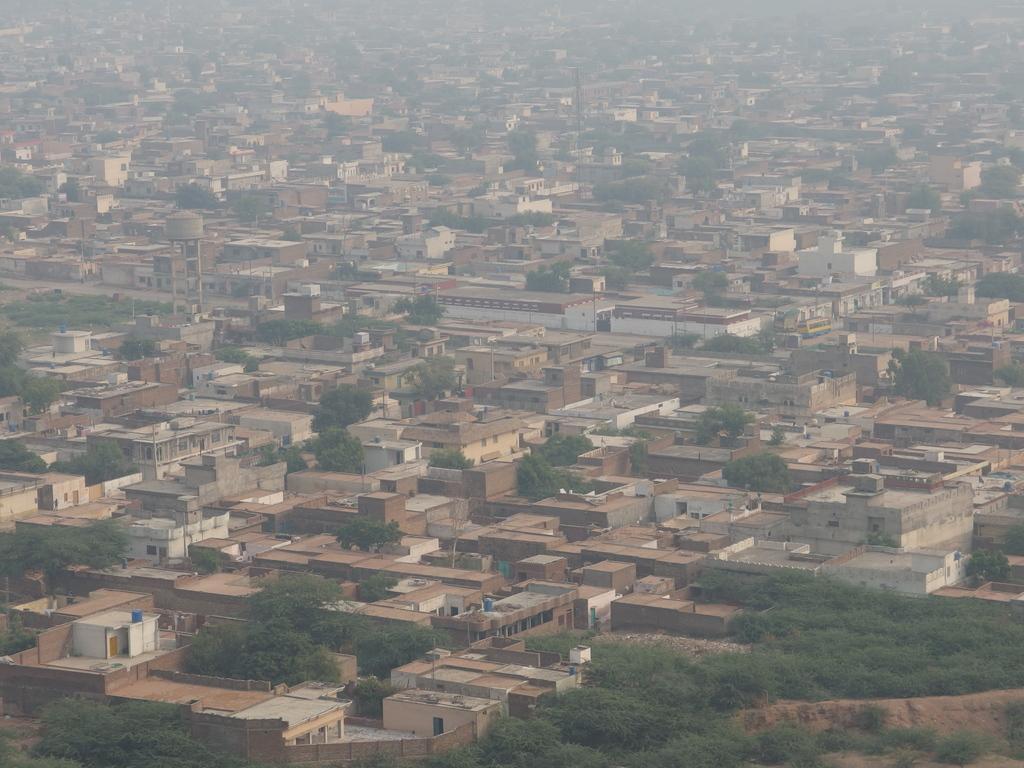Can you describe this image briefly? In the image we can see the houses and trees. 